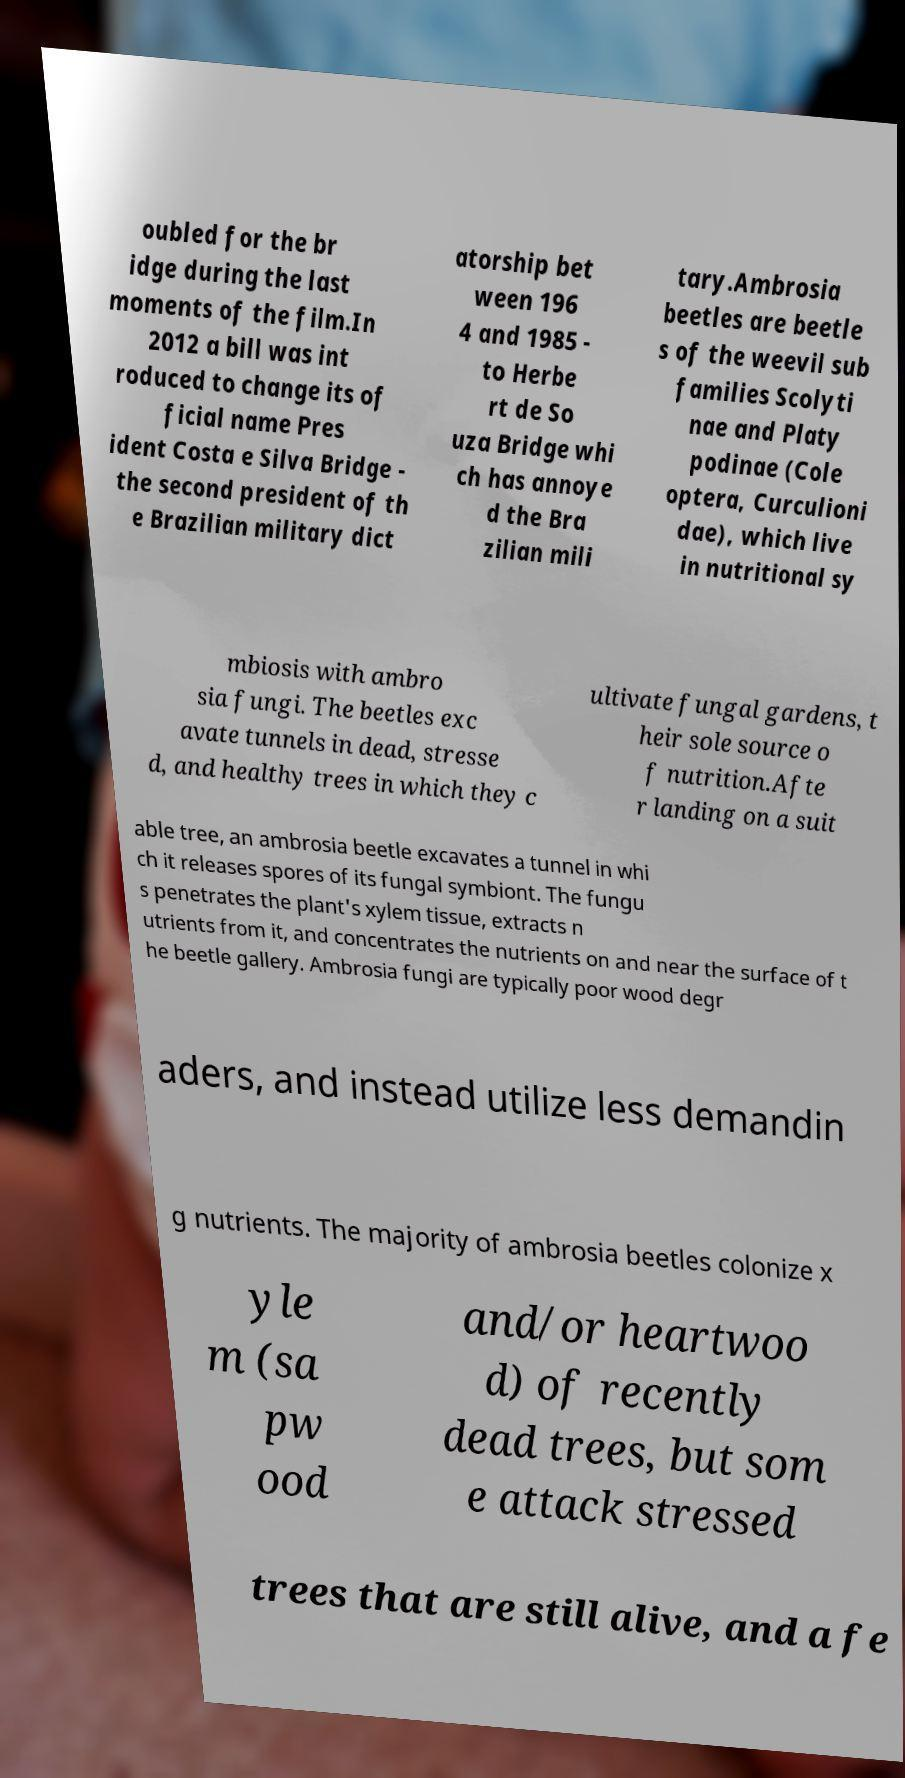For documentation purposes, I need the text within this image transcribed. Could you provide that? oubled for the br idge during the last moments of the film.In 2012 a bill was int roduced to change its of ficial name Pres ident Costa e Silva Bridge - the second president of th e Brazilian military dict atorship bet ween 196 4 and 1985 - to Herbe rt de So uza Bridge whi ch has annoye d the Bra zilian mili tary.Ambrosia beetles are beetle s of the weevil sub families Scolyti nae and Platy podinae (Cole optera, Curculioni dae), which live in nutritional sy mbiosis with ambro sia fungi. The beetles exc avate tunnels in dead, stresse d, and healthy trees in which they c ultivate fungal gardens, t heir sole source o f nutrition.Afte r landing on a suit able tree, an ambrosia beetle excavates a tunnel in whi ch it releases spores of its fungal symbiont. The fungu s penetrates the plant's xylem tissue, extracts n utrients from it, and concentrates the nutrients on and near the surface of t he beetle gallery. Ambrosia fungi are typically poor wood degr aders, and instead utilize less demandin g nutrients. The majority of ambrosia beetles colonize x yle m (sa pw ood and/or heartwoo d) of recently dead trees, but som e attack stressed trees that are still alive, and a fe 